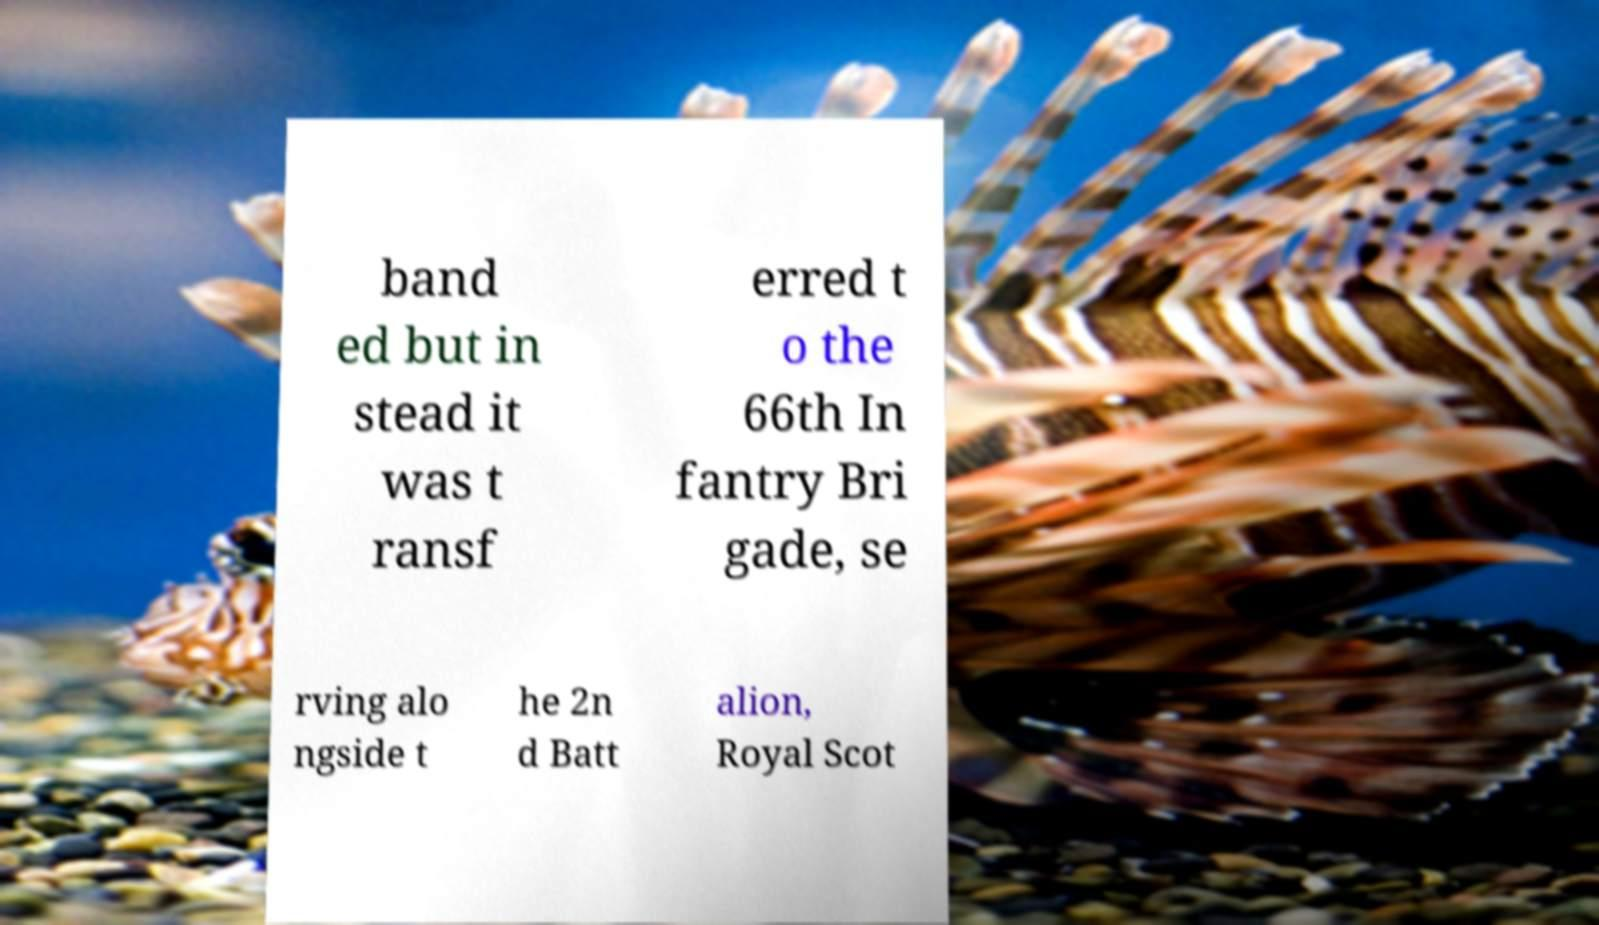Could you assist in decoding the text presented in this image and type it out clearly? band ed but in stead it was t ransf erred t o the 66th In fantry Bri gade, se rving alo ngside t he 2n d Batt alion, Royal Scot 